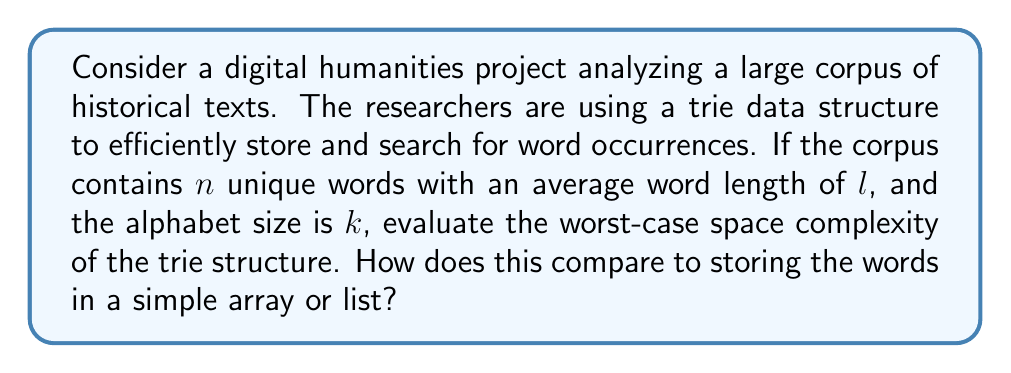Teach me how to tackle this problem. To evaluate the space complexity of the trie structure, we need to consider the following:

1. Trie structure:
   - Each node in the trie represents a character.
   - The number of children for each node is at most $k$ (the alphabet size).
   - The depth of the trie is at most $l$ (the average word length).
   - In the worst case, each word creates a unique path in the trie.

2. Space complexity analysis:
   a) Worst-case scenario:
      - Each word creates a new path of length $l$.
      - Total number of nodes: $O(n \cdot l)$
      - Each node stores $k$ pointers to its children.
      - Space required for each node: $O(k)$

   b) Total space complexity:
      $$O(n \cdot l \cdot k)$$

3. Comparison with array/list storage:
   - Storing words in an array or list would require $O(n \cdot l)$ space.
   - Each word occupies $l$ characters on average.
   - Total space for $n$ words: $n \cdot l$

4. Efficiency consideration:
   - While the trie has a higher space complexity, it offers faster search and prefix matching operations, which are often crucial in digital humanities research.
   - The actual space usage of a trie is usually less than the worst-case scenario, as words often share common prefixes.

5. Trade-off:
   - The choice between a trie and a simple array depends on the specific requirements of the digital humanities project, such as the need for prefix matching, search speed, and available memory resources.
Answer: The worst-case space complexity of the trie structure is $O(n \cdot l \cdot k)$, where $n$ is the number of unique words, $l$ is the average word length, and $k$ is the alphabet size. This is higher than the $O(n \cdot l)$ space required for storing words in a simple array or list. However, the trie offers faster search and prefix matching operations, which may be beneficial for digital humanities research despite the increased space complexity. 